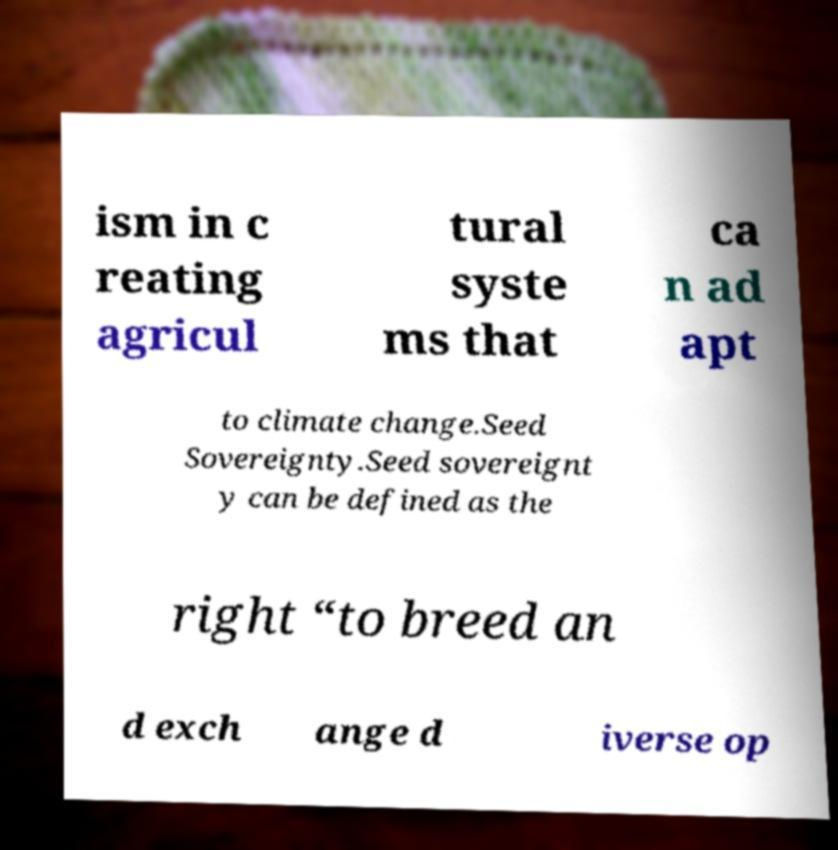Could you extract and type out the text from this image? ism in c reating agricul tural syste ms that ca n ad apt to climate change.Seed Sovereignty.Seed sovereignt y can be defined as the right “to breed an d exch ange d iverse op 